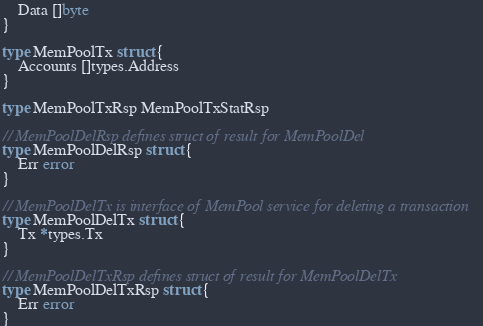Convert code to text. <code><loc_0><loc_0><loc_500><loc_500><_Go_>	Data []byte
}

type MemPoolTx struct {
	Accounts []types.Address
}

type MemPoolTxRsp MemPoolTxStatRsp

// MemPoolDelRsp defines struct of result for MemPoolDel
type MemPoolDelRsp struct {
	Err error
}

// MemPoolDelTx is interface of MemPool service for deleting a transaction
type MemPoolDelTx struct {
	Tx *types.Tx
}

// MemPoolDelTxRsp defines struct of result for MemPoolDelTx
type MemPoolDelTxRsp struct {
	Err error
}
</code> 